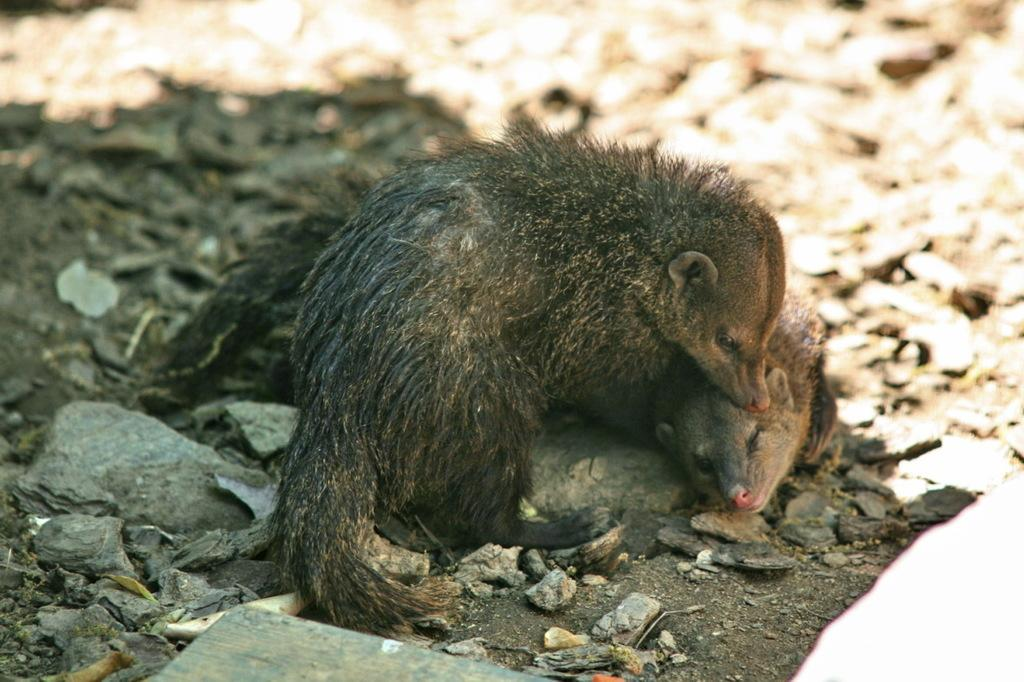How many animals are present in the image? There are two animals in the image. What color are the animals? The animals are black in color. What else can be seen in the image besides the animals? There are stones visible in the image. Can you describe the background of the image? The background of the image is blurred. What type of balls are the animals playing with in the image? There are no balls present in the image; the animals are not engaged in any game or activity involving balls. 